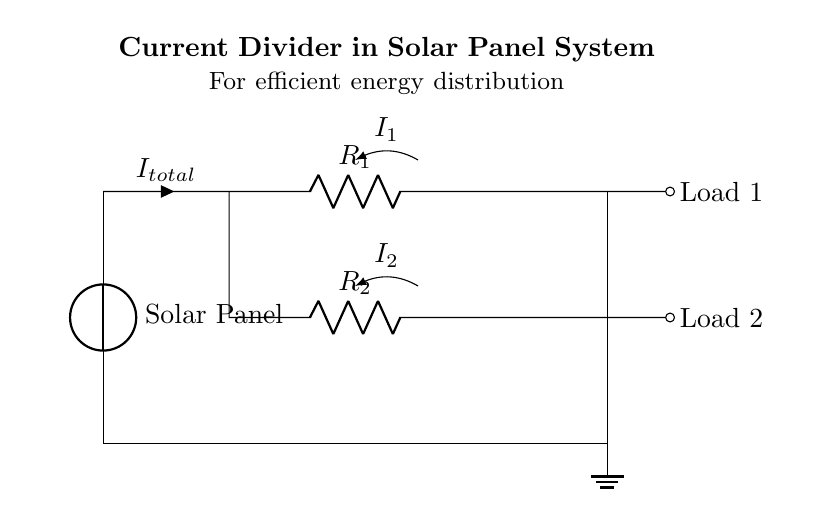What does the current divider do? The current divider distributes the total current from the source into multiple branches. In this circuit, it divides the current into two paths, influencing how much current each load receives.
Answer: divides current What are the resistor values in the circuit? The circuit diagram does not specify the numerical values of the resistors R1 and R2. Their values would determine the current division between Load 1 and Load 2.
Answer: Not specified How many loads are connected in this circuit? The diagram shows two loads connected in parallel to the current divider. Each load receives a portion of the total current, depending on the resistances.
Answer: Two loads What is the total current entering the divider? The total current entering the divider is labeled as I total in the circuit. This is the current from the solar panel before it is divided between the two branches.
Answer: I total Which load receives less current? Load 2 receives less current when compared to Load 1. This is typically due to the relative resistance values, where a higher resistance would result in lower current through that branch according to Ohm's law.
Answer: Load 2 How is the current through Load 1 represented? The current through Load 1 is represented as I1 in the diagram. This shows the amount of current flowing through that specific path derived from the total current.
Answer: I1 Why is it important to use a current divider in solar panel systems? A current divider is crucial in solar panel systems as it optimizes energy distribution to various loads, ensuring that each load gets the appropriate share of the total energy generated by the solar panel system.
Answer: Optimizes energy distribution 